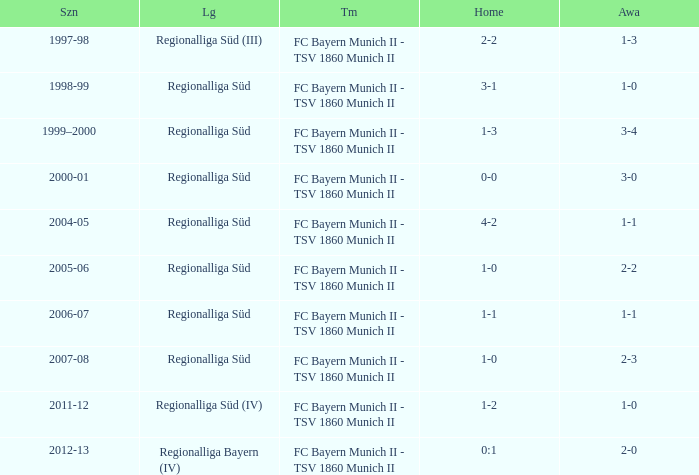What league has a 3-1 home? Regionalliga Süd. 